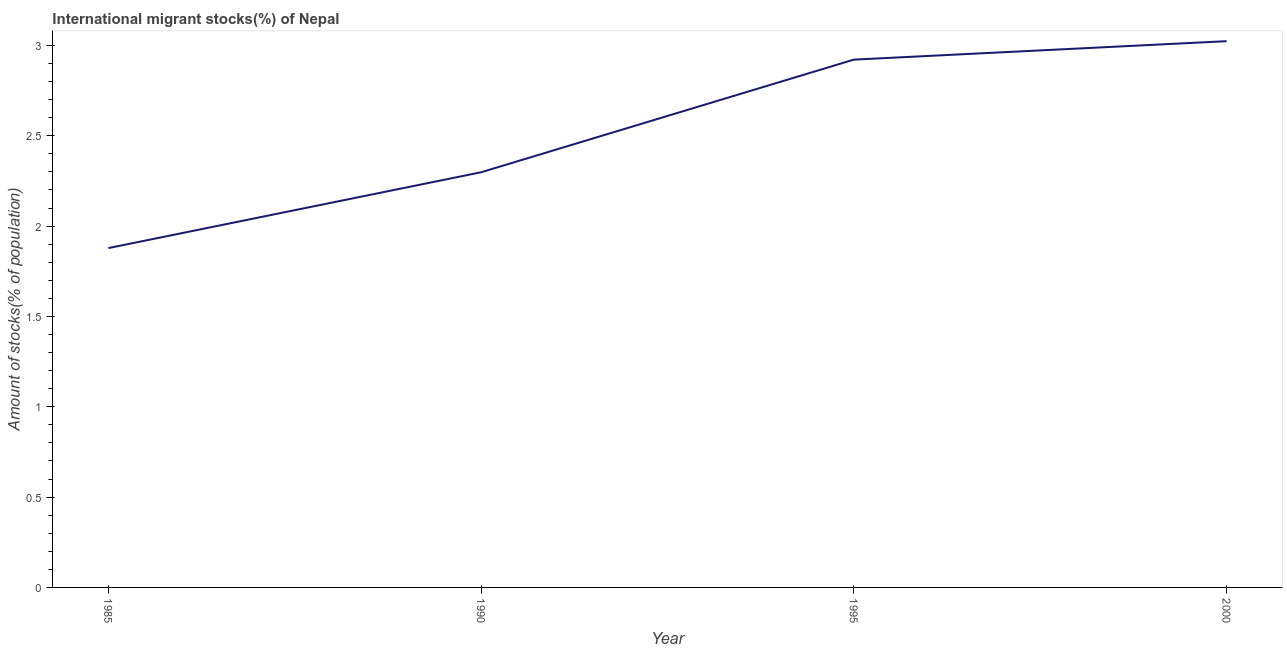What is the number of international migrant stocks in 1985?
Make the answer very short. 1.88. Across all years, what is the maximum number of international migrant stocks?
Provide a short and direct response. 3.02. Across all years, what is the minimum number of international migrant stocks?
Give a very brief answer. 1.88. In which year was the number of international migrant stocks maximum?
Offer a very short reply. 2000. In which year was the number of international migrant stocks minimum?
Your answer should be very brief. 1985. What is the sum of the number of international migrant stocks?
Your response must be concise. 10.12. What is the difference between the number of international migrant stocks in 1985 and 2000?
Make the answer very short. -1.15. What is the average number of international migrant stocks per year?
Provide a short and direct response. 2.53. What is the median number of international migrant stocks?
Your answer should be compact. 2.61. In how many years, is the number of international migrant stocks greater than 1 %?
Ensure brevity in your answer.  4. What is the ratio of the number of international migrant stocks in 1990 to that in 1995?
Give a very brief answer. 0.79. Is the number of international migrant stocks in 1995 less than that in 2000?
Ensure brevity in your answer.  Yes. What is the difference between the highest and the second highest number of international migrant stocks?
Provide a succinct answer. 0.1. Is the sum of the number of international migrant stocks in 1995 and 2000 greater than the maximum number of international migrant stocks across all years?
Provide a short and direct response. Yes. What is the difference between the highest and the lowest number of international migrant stocks?
Provide a succinct answer. 1.15. Does the number of international migrant stocks monotonically increase over the years?
Provide a succinct answer. Yes. How many lines are there?
Your response must be concise. 1. What is the difference between two consecutive major ticks on the Y-axis?
Offer a terse response. 0.5. Are the values on the major ticks of Y-axis written in scientific E-notation?
Offer a terse response. No. Does the graph contain any zero values?
Offer a very short reply. No. What is the title of the graph?
Ensure brevity in your answer.  International migrant stocks(%) of Nepal. What is the label or title of the Y-axis?
Provide a short and direct response. Amount of stocks(% of population). What is the Amount of stocks(% of population) of 1985?
Make the answer very short. 1.88. What is the Amount of stocks(% of population) in 1990?
Keep it short and to the point. 2.3. What is the Amount of stocks(% of population) of 1995?
Ensure brevity in your answer.  2.92. What is the Amount of stocks(% of population) in 2000?
Keep it short and to the point. 3.02. What is the difference between the Amount of stocks(% of population) in 1985 and 1990?
Your answer should be compact. -0.42. What is the difference between the Amount of stocks(% of population) in 1985 and 1995?
Your answer should be compact. -1.04. What is the difference between the Amount of stocks(% of population) in 1985 and 2000?
Your answer should be very brief. -1.15. What is the difference between the Amount of stocks(% of population) in 1990 and 1995?
Keep it short and to the point. -0.62. What is the difference between the Amount of stocks(% of population) in 1990 and 2000?
Keep it short and to the point. -0.73. What is the difference between the Amount of stocks(% of population) in 1995 and 2000?
Ensure brevity in your answer.  -0.1. What is the ratio of the Amount of stocks(% of population) in 1985 to that in 1990?
Keep it short and to the point. 0.82. What is the ratio of the Amount of stocks(% of population) in 1985 to that in 1995?
Offer a very short reply. 0.64. What is the ratio of the Amount of stocks(% of population) in 1985 to that in 2000?
Your response must be concise. 0.62. What is the ratio of the Amount of stocks(% of population) in 1990 to that in 1995?
Your answer should be very brief. 0.79. What is the ratio of the Amount of stocks(% of population) in 1990 to that in 2000?
Ensure brevity in your answer.  0.76. 